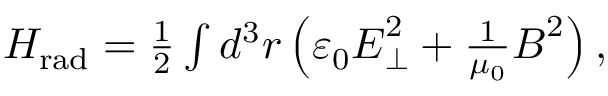Convert formula to latex. <formula><loc_0><loc_0><loc_500><loc_500>\begin{array} { r } { H _ { r a d } = \frac { 1 } { 2 } \int d ^ { 3 } r \left ( \varepsilon _ { 0 } E _ { \perp } ^ { 2 } + \frac { 1 } { \mu _ { 0 } } B ^ { 2 } \right ) , } \end{array}</formula> 